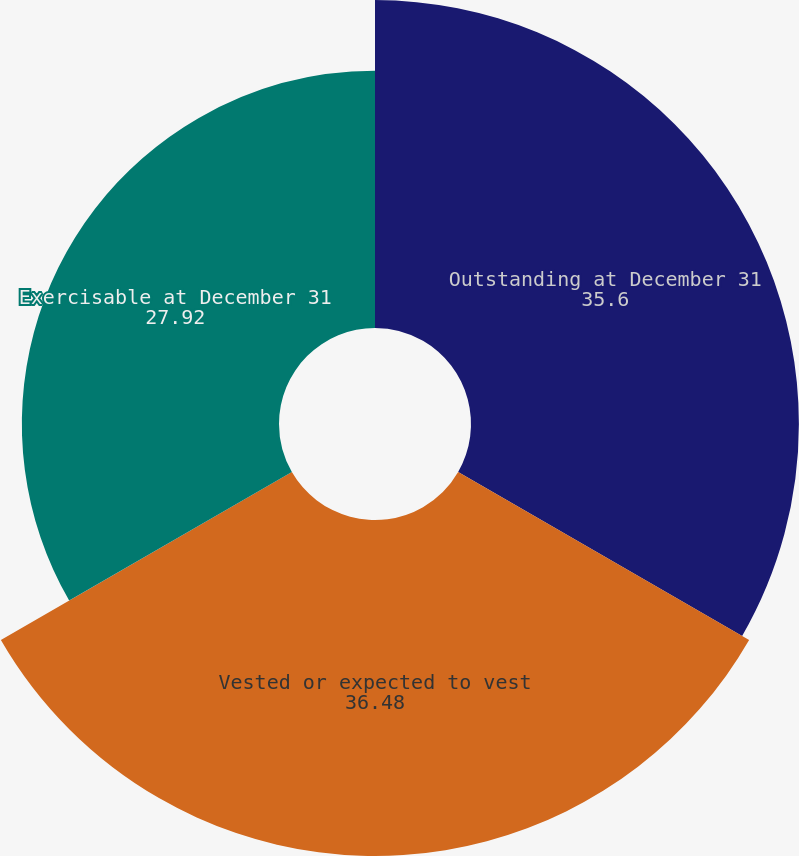<chart> <loc_0><loc_0><loc_500><loc_500><pie_chart><fcel>Outstanding at December 31<fcel>Vested or expected to vest<fcel>Exercisable at December 31<nl><fcel>35.6%<fcel>36.48%<fcel>27.92%<nl></chart> 